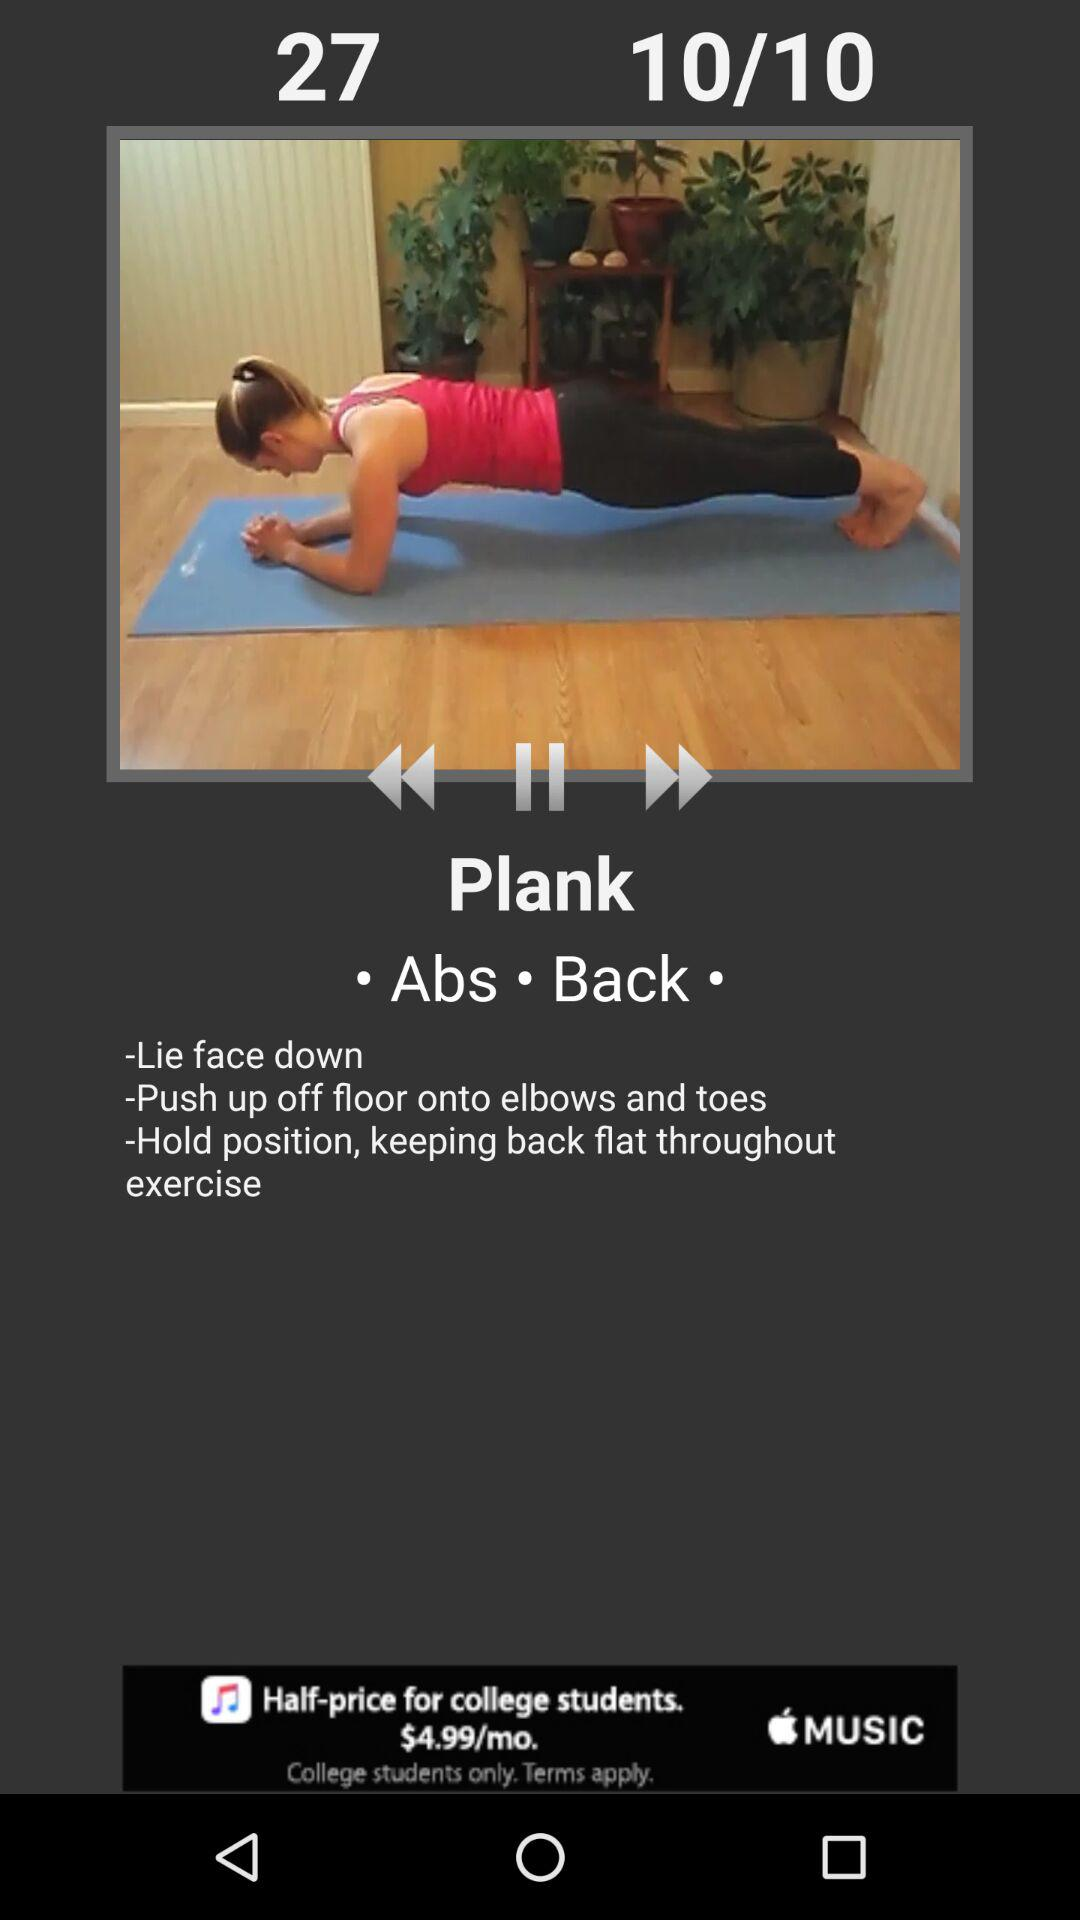What is the exercise name? The exercise name is Plank. 